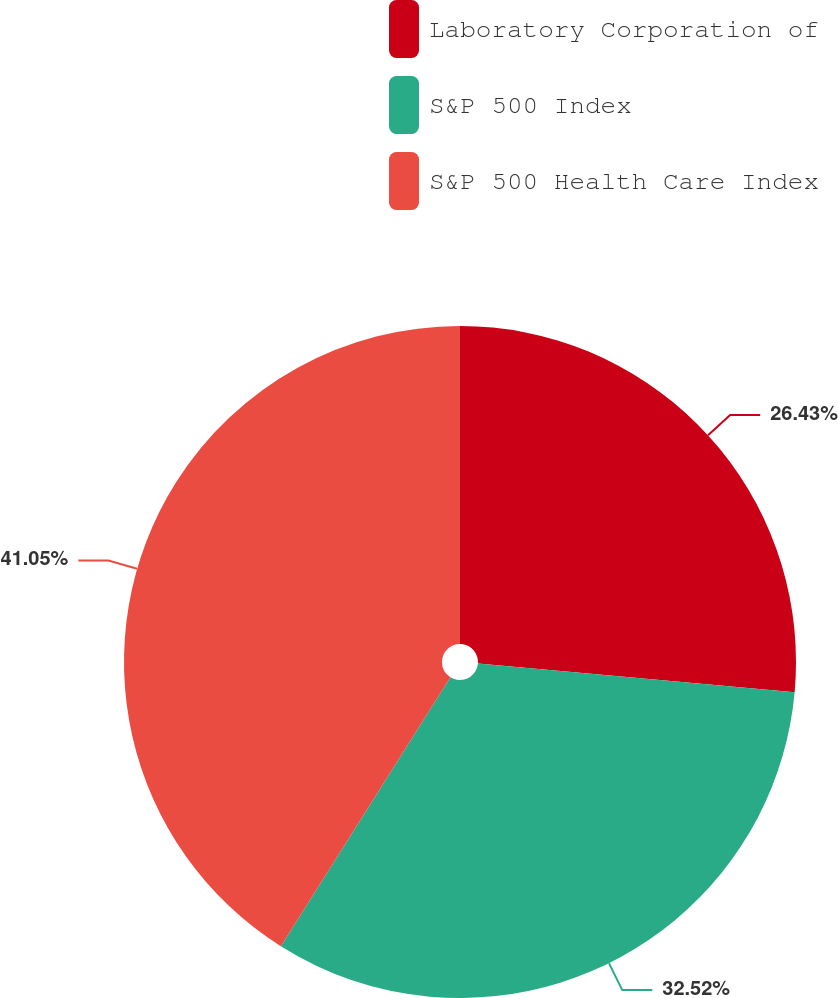Convert chart. <chart><loc_0><loc_0><loc_500><loc_500><pie_chart><fcel>Laboratory Corporation of<fcel>S&P 500 Index<fcel>S&P 500 Health Care Index<nl><fcel>26.43%<fcel>32.52%<fcel>41.05%<nl></chart> 